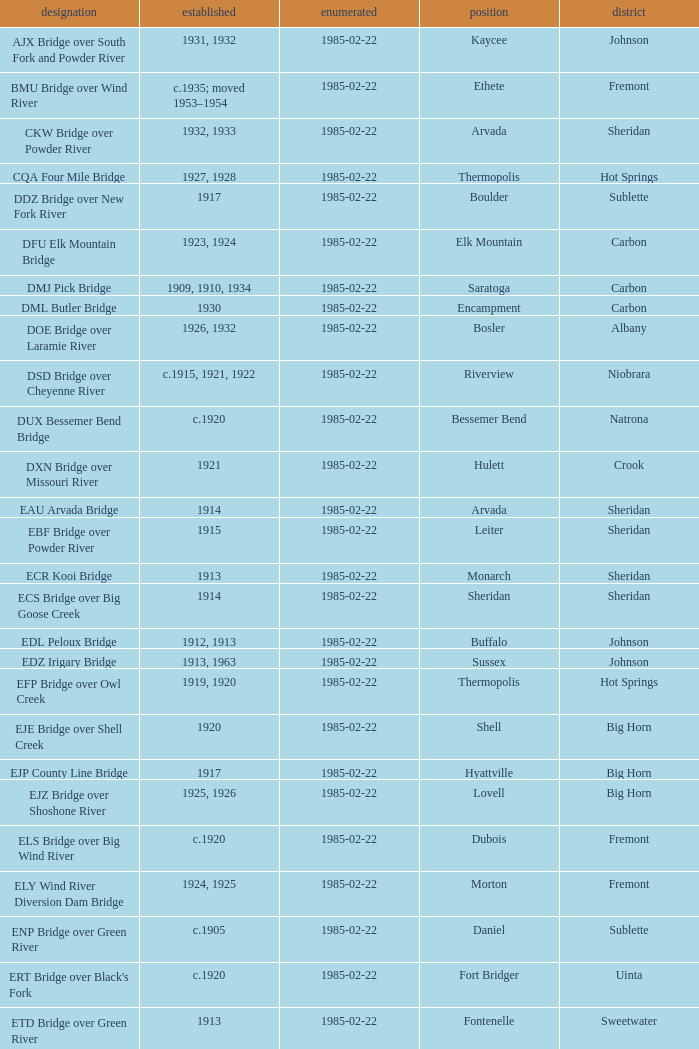Could you help me parse every detail presented in this table? {'header': ['designation', 'established', 'enumerated', 'position', 'district'], 'rows': [['AJX Bridge over South Fork and Powder River', '1931, 1932', '1985-02-22', 'Kaycee', 'Johnson'], ['BMU Bridge over Wind River', 'c.1935; moved 1953–1954', '1985-02-22', 'Ethete', 'Fremont'], ['CKW Bridge over Powder River', '1932, 1933', '1985-02-22', 'Arvada', 'Sheridan'], ['CQA Four Mile Bridge', '1927, 1928', '1985-02-22', 'Thermopolis', 'Hot Springs'], ['DDZ Bridge over New Fork River', '1917', '1985-02-22', 'Boulder', 'Sublette'], ['DFU Elk Mountain Bridge', '1923, 1924', '1985-02-22', 'Elk Mountain', 'Carbon'], ['DMJ Pick Bridge', '1909, 1910, 1934', '1985-02-22', 'Saratoga', 'Carbon'], ['DML Butler Bridge', '1930', '1985-02-22', 'Encampment', 'Carbon'], ['DOE Bridge over Laramie River', '1926, 1932', '1985-02-22', 'Bosler', 'Albany'], ['DSD Bridge over Cheyenne River', 'c.1915, 1921, 1922', '1985-02-22', 'Riverview', 'Niobrara'], ['DUX Bessemer Bend Bridge', 'c.1920', '1985-02-22', 'Bessemer Bend', 'Natrona'], ['DXN Bridge over Missouri River', '1921', '1985-02-22', 'Hulett', 'Crook'], ['EAU Arvada Bridge', '1914', '1985-02-22', 'Arvada', 'Sheridan'], ['EBF Bridge over Powder River', '1915', '1985-02-22', 'Leiter', 'Sheridan'], ['ECR Kooi Bridge', '1913', '1985-02-22', 'Monarch', 'Sheridan'], ['ECS Bridge over Big Goose Creek', '1914', '1985-02-22', 'Sheridan', 'Sheridan'], ['EDL Peloux Bridge', '1912, 1913', '1985-02-22', 'Buffalo', 'Johnson'], ['EDZ Irigary Bridge', '1913, 1963', '1985-02-22', 'Sussex', 'Johnson'], ['EFP Bridge over Owl Creek', '1919, 1920', '1985-02-22', 'Thermopolis', 'Hot Springs'], ['EJE Bridge over Shell Creek', '1920', '1985-02-22', 'Shell', 'Big Horn'], ['EJP County Line Bridge', '1917', '1985-02-22', 'Hyattville', 'Big Horn'], ['EJZ Bridge over Shoshone River', '1925, 1926', '1985-02-22', 'Lovell', 'Big Horn'], ['ELS Bridge over Big Wind River', 'c.1920', '1985-02-22', 'Dubois', 'Fremont'], ['ELY Wind River Diversion Dam Bridge', '1924, 1925', '1985-02-22', 'Morton', 'Fremont'], ['ENP Bridge over Green River', 'c.1905', '1985-02-22', 'Daniel', 'Sublette'], ["ERT Bridge over Black's Fork", 'c.1920', '1985-02-22', 'Fort Bridger', 'Uinta'], ['ETD Bridge over Green River', '1913', '1985-02-22', 'Fontenelle', 'Sweetwater'], ['ETR Big Island Bridge', '1909, 1910', '1985-02-22', 'Green River', 'Sweetwater'], ['EWZ Bridge over East Channel of Laramie River', '1913, 1914', '1985-02-22', 'Wheatland', 'Platte'], ['Hayden Arch Bridge', '1924, 1925', '1985-02-22', 'Cody', 'Park'], ['Rairden Bridge', '1916', '1985-02-22', 'Manderson', 'Big Horn']]} What is the administrative division of the bridge in boulder? Sublette. 